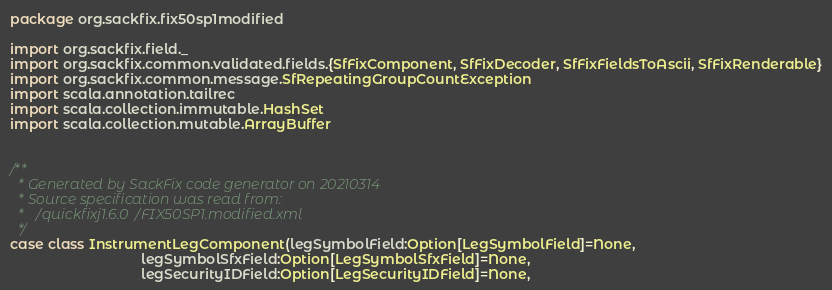<code> <loc_0><loc_0><loc_500><loc_500><_Scala_>package org.sackfix.fix50sp1modified

import org.sackfix.field._
import org.sackfix.common.validated.fields.{SfFixComponent, SfFixDecoder, SfFixFieldsToAscii, SfFixRenderable}
import org.sackfix.common.message.SfRepeatingGroupCountException
import scala.annotation.tailrec
import scala.collection.immutable.HashSet
import scala.collection.mutable.ArrayBuffer


/**
  * Generated by SackFix code generator on 20210314
  * Source specification was read from:
  *   /quickfixj1.6.0/FIX50SP1.modified.xml
  */
case class InstrumentLegComponent(legSymbolField:Option[LegSymbolField]=None,
                                  legSymbolSfxField:Option[LegSymbolSfxField]=None,
                                  legSecurityIDField:Option[LegSecurityIDField]=None,</code> 